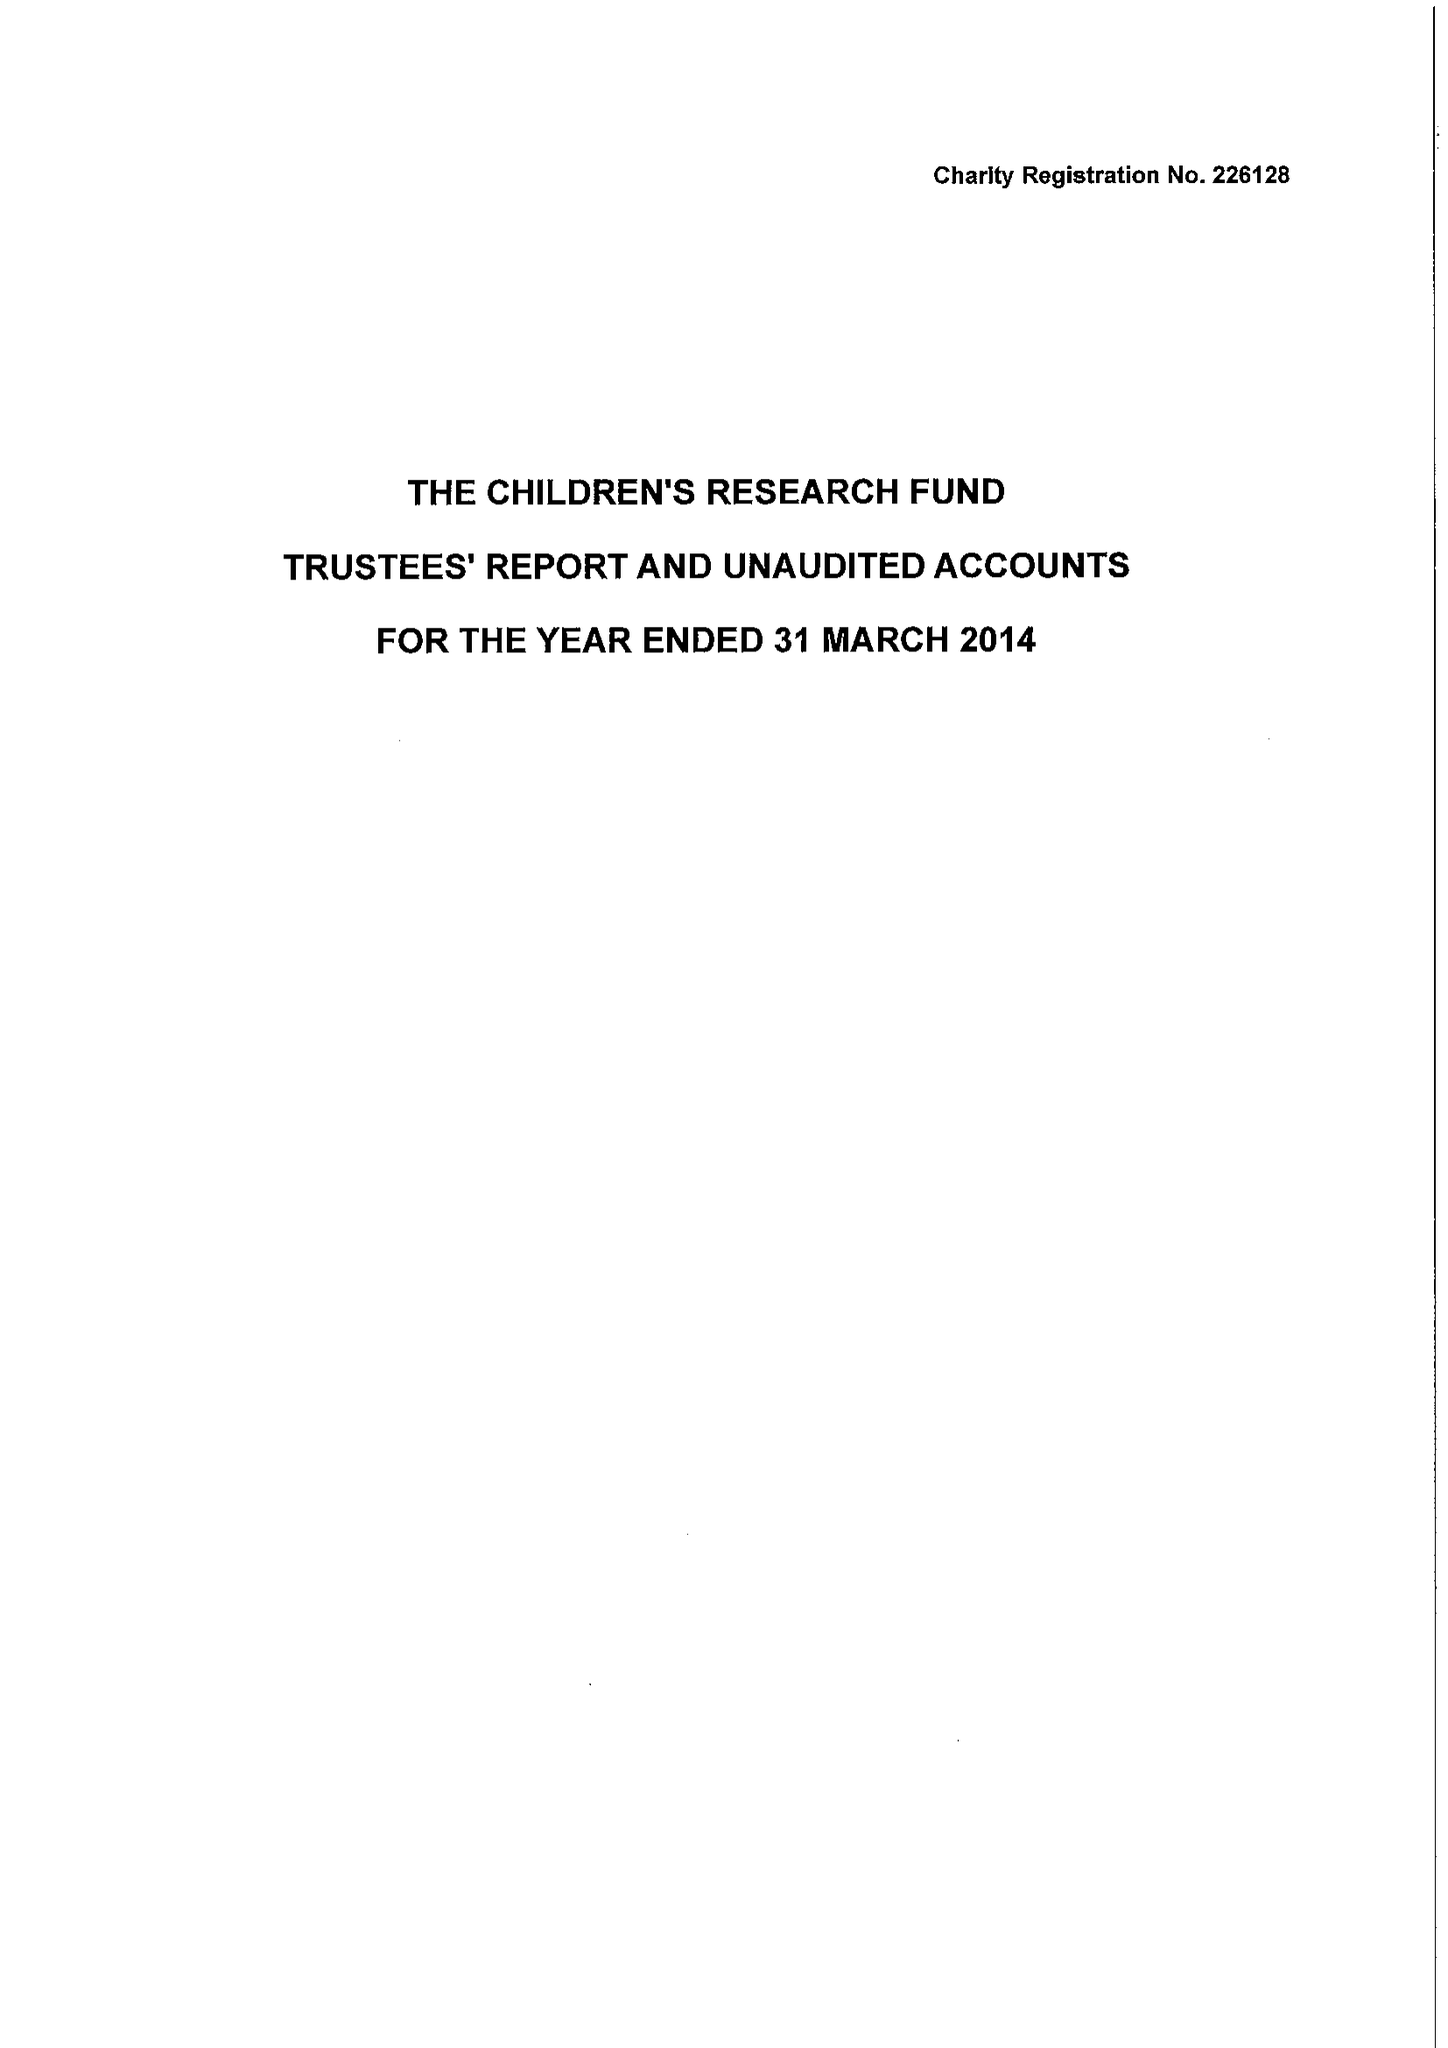What is the value for the charity_number?
Answer the question using a single word or phrase. 226128 